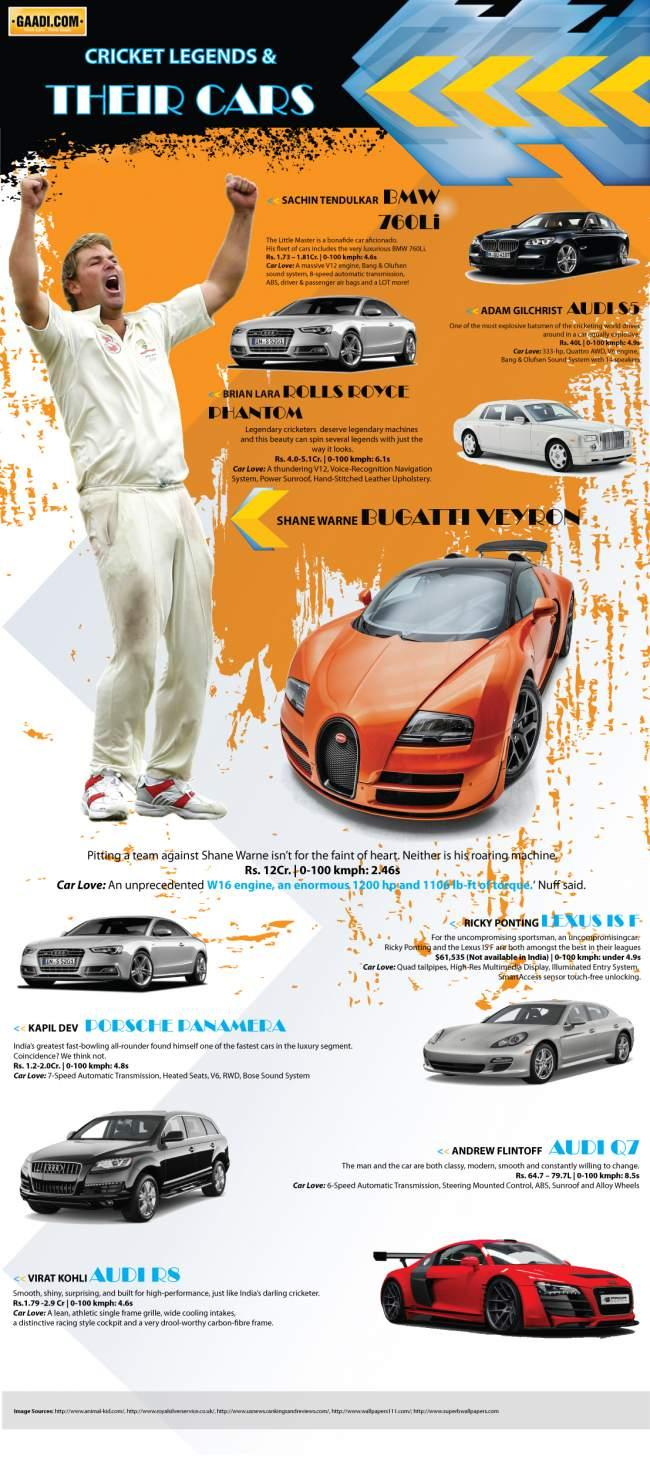Point out several critical features in this image. The color of the Audi owned by Kohli is red. The car in orange color is a Bugatti Veyron. Lexus is not available in India among the car brands of Lexus, Audi, and BMW. The cricketers, Adam Gilchrist, Andrew Flintoff, and Virat Kohli, each own an Audi car. The model number of the car that is black is 760Li. 